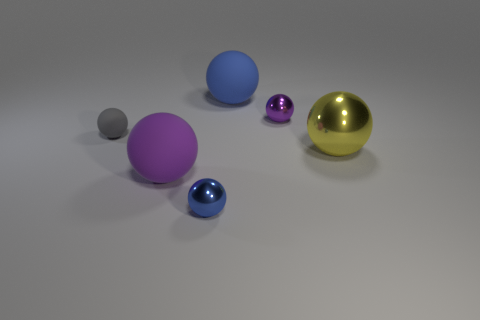Does the small purple ball have the same material as the big ball left of the blue metallic thing? Based on the image, it appears that the small purple ball and the large ball to the left of the blue object do not have the same material. The small purple ball has a matte finish, indicating a lack of reflectiveness, whereas the large ball has a reflective surface similar to the golden ball, suggesting a metallic or polished material, thus they are different in material properties. 